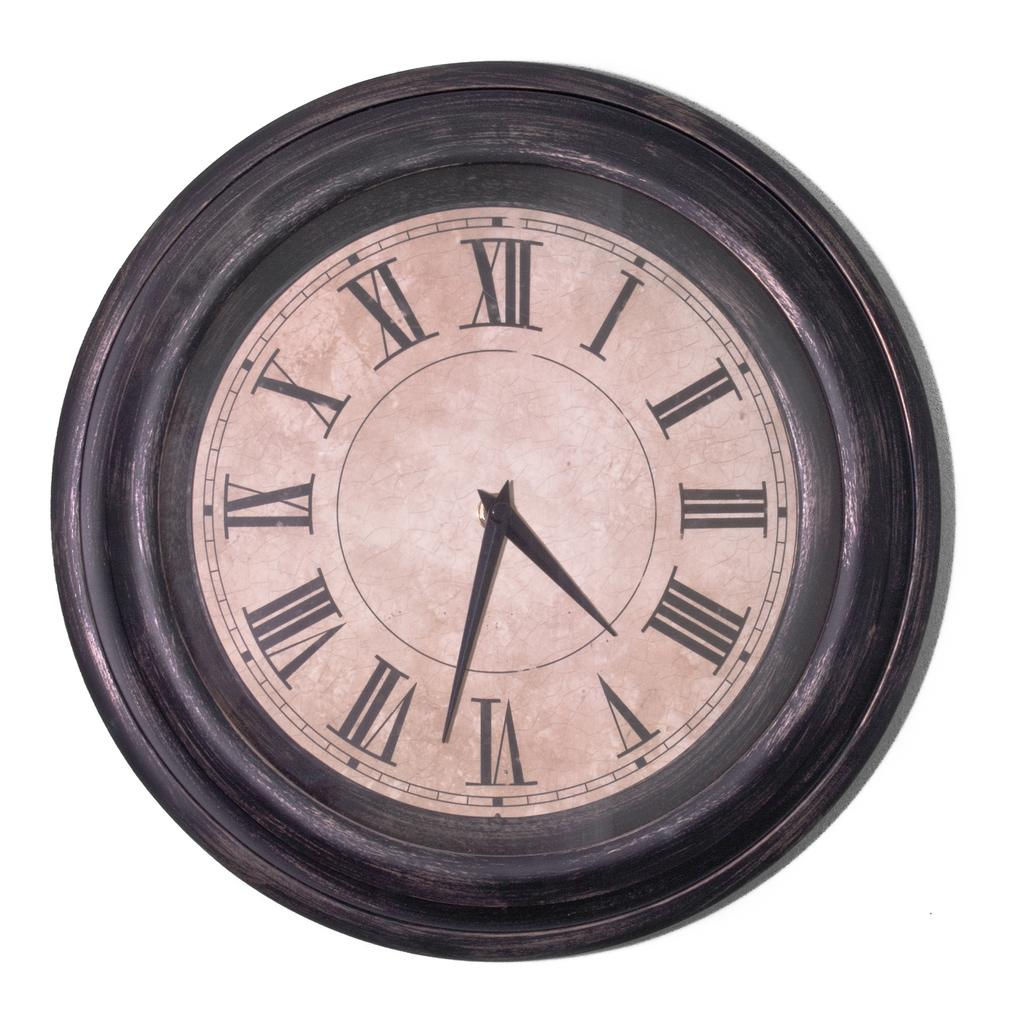<image>
Present a compact description of the photo's key features. A clock with roman numerals on it shows the time as 4:32. 